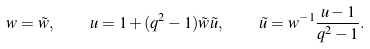<formula> <loc_0><loc_0><loc_500><loc_500>w = \tilde { w } , \quad u = 1 + ( q ^ { 2 } - 1 ) \tilde { w } \tilde { u } , \quad \tilde { u } = w ^ { - 1 } \frac { u - 1 } { q ^ { 2 } - 1 } .</formula> 